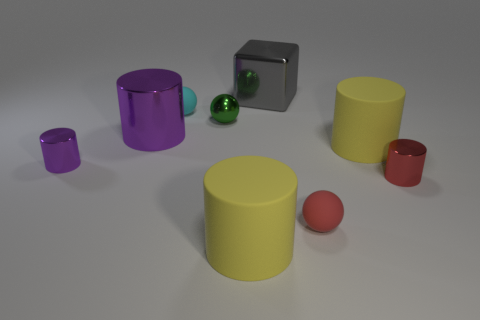Subtract all matte balls. How many balls are left? 1 Subtract all cyan spheres. How many spheres are left? 2 Subtract 5 cylinders. How many cylinders are left? 0 Add 3 large metallic cylinders. How many large metallic cylinders exist? 4 Subtract 1 gray cubes. How many objects are left? 8 Subtract all cylinders. How many objects are left? 4 Subtract all red cylinders. Subtract all green balls. How many cylinders are left? 4 Subtract all green cubes. How many gray balls are left? 0 Subtract all red cylinders. Subtract all big yellow rubber things. How many objects are left? 6 Add 7 tiny red metal things. How many tiny red metal things are left? 8 